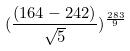<formula> <loc_0><loc_0><loc_500><loc_500>( \frac { ( 1 6 4 - 2 4 2 ) } { \sqrt { 5 } } ) ^ { \frac { 2 8 3 } { 9 } }</formula> 